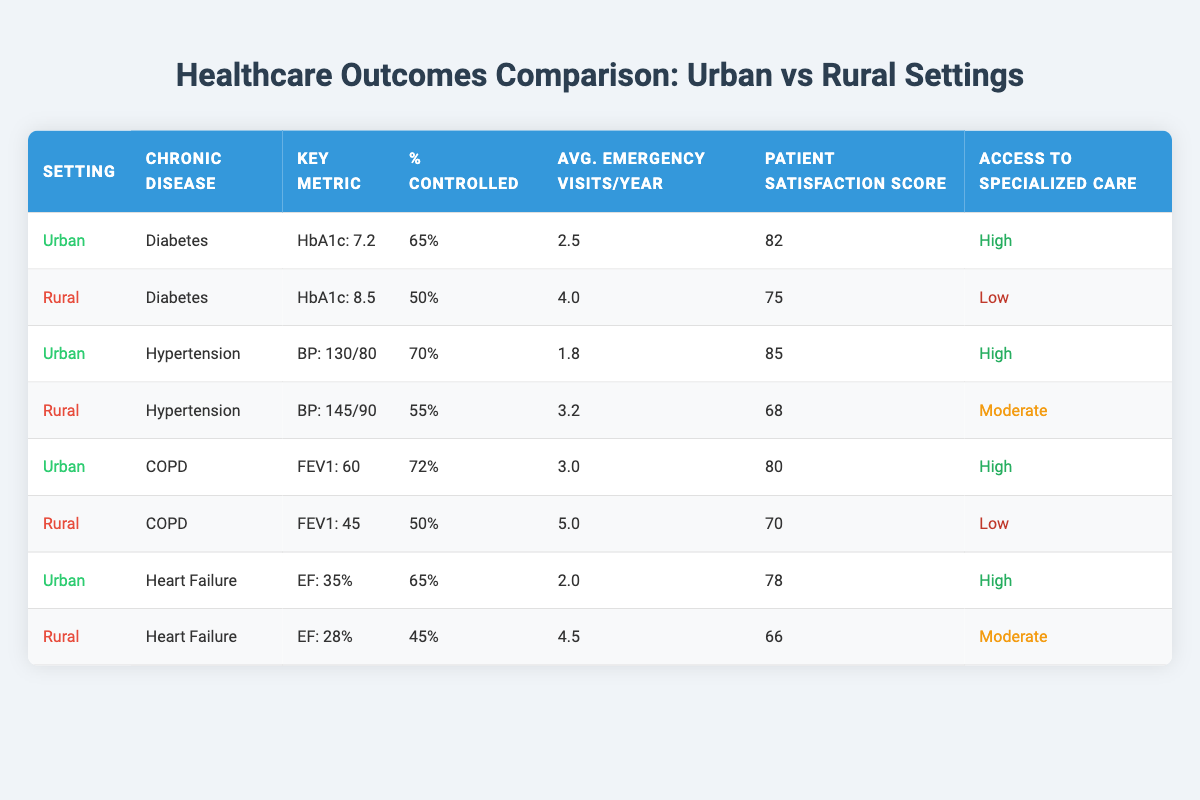What is the average HbA1c level for diabetes patients in urban settings? The table shows that the average HbA1c level for diabetes patients in urban settings is 7.2.
Answer: 7.2 What percentage of hypertension patients are controlled in rural settings? According to the table, the percentage of hypertension patients controlled in rural settings is 55%.
Answer: 55% Is patient satisfaction higher for COPD patients in urban or rural settings? The urban setting has a patient satisfaction score of 80 for COPD patients, while the rural setting has a score of 70. Therefore, urban settings have higher patient satisfaction.
Answer: Urban settings What is the difference in average emergency visits per year between heart failure patients in urban vs rural settings? For heart failure patients, the average emergency visits per year in urban settings is 2.0 while in rural settings it is 4.5. The difference is 4.5 - 2.0 = 2.5 visits per year.
Answer: 2.5 Are diabetes patients in urban settings experiencing better healthcare outcomes than those in rural settings? Yes, urban diabetes patients have a lower average HbA1c (7.2 vs 8.5), a higher percentage controlled (65% vs 50%), and fewer average emergency visits (2.5 vs 4.0). Therefore, they are experiencing better healthcare outcomes.
Answer: Yes What is the average patient satisfaction score for chronic disease patients in rural settings? The average patient satisfaction scores for chronic disease patients in rural settings are 75 (Diabetes) + 68 (Hypertension) + 70 (COPD) + 66 (Heart Failure) = 279. There are 4 data points, so the average is 279/4 = 69.75. Rounded, this is approximately 70.
Answer: 70 Which chronic disease has the highest percentage controlled in urban settings? The table indicates that hypertension patients have the highest percentage controlled in urban settings at 70%.
Answer: Hypertension In which setting is access to specialized care considered high? The table shows that access to specialized care is considered high in the urban setting for diabetes, hypertension, COPD, and heart failure patients.
Answer: Urban setting What is the average FEV1 for COPD patients in rural settings? For COPD patients in rural settings, the average FEV1 is provided as 45 in the table.
Answer: 45 